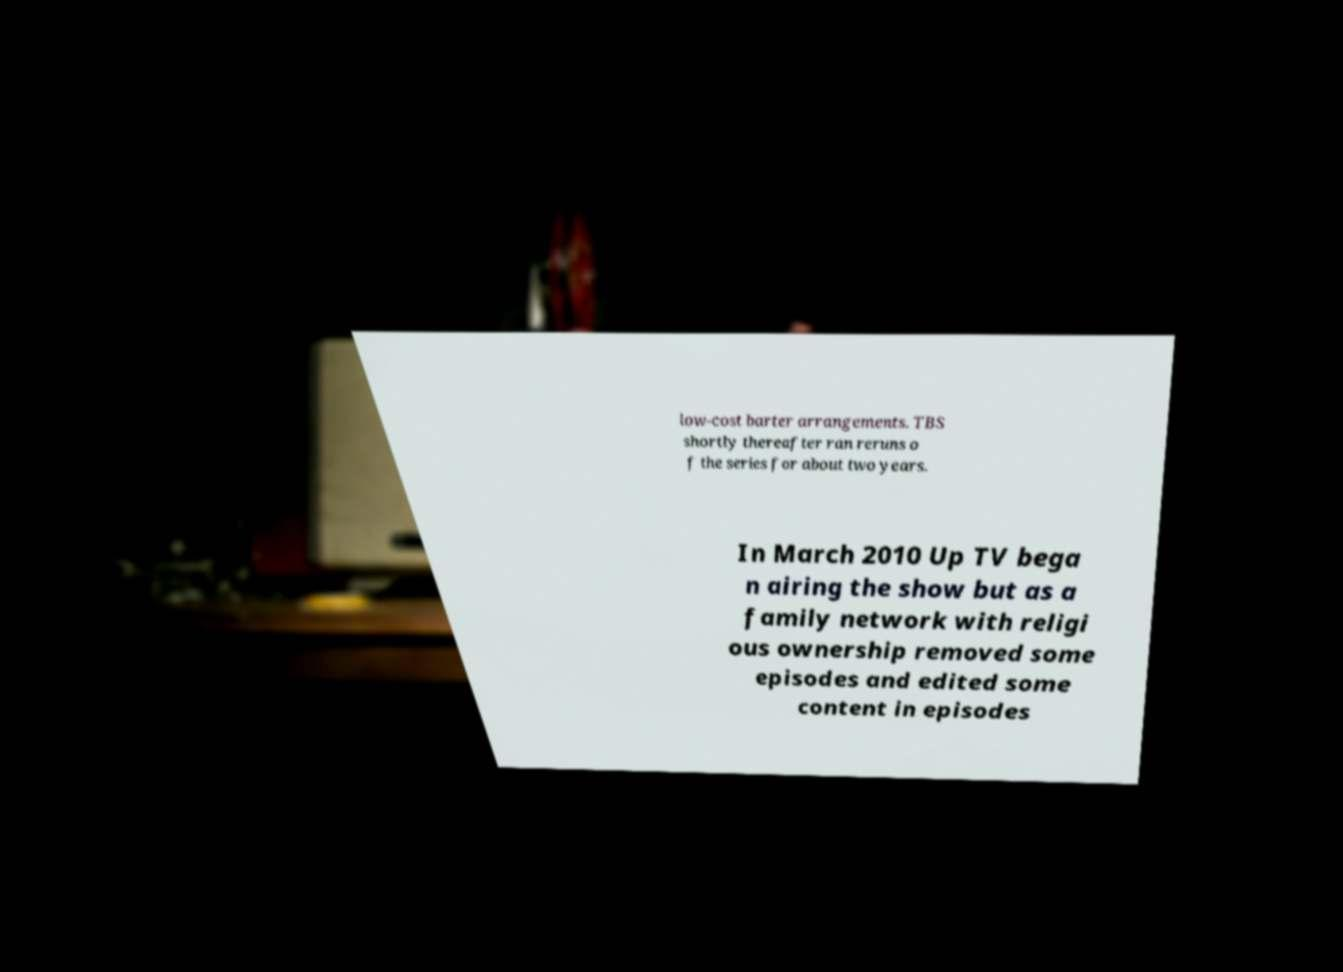Could you extract and type out the text from this image? low-cost barter arrangements. TBS shortly thereafter ran reruns o f the series for about two years. In March 2010 Up TV bega n airing the show but as a family network with religi ous ownership removed some episodes and edited some content in episodes 